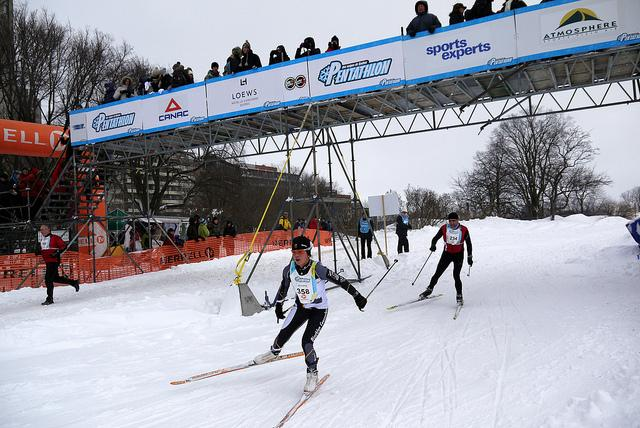What type of signs are shown? sponsors 